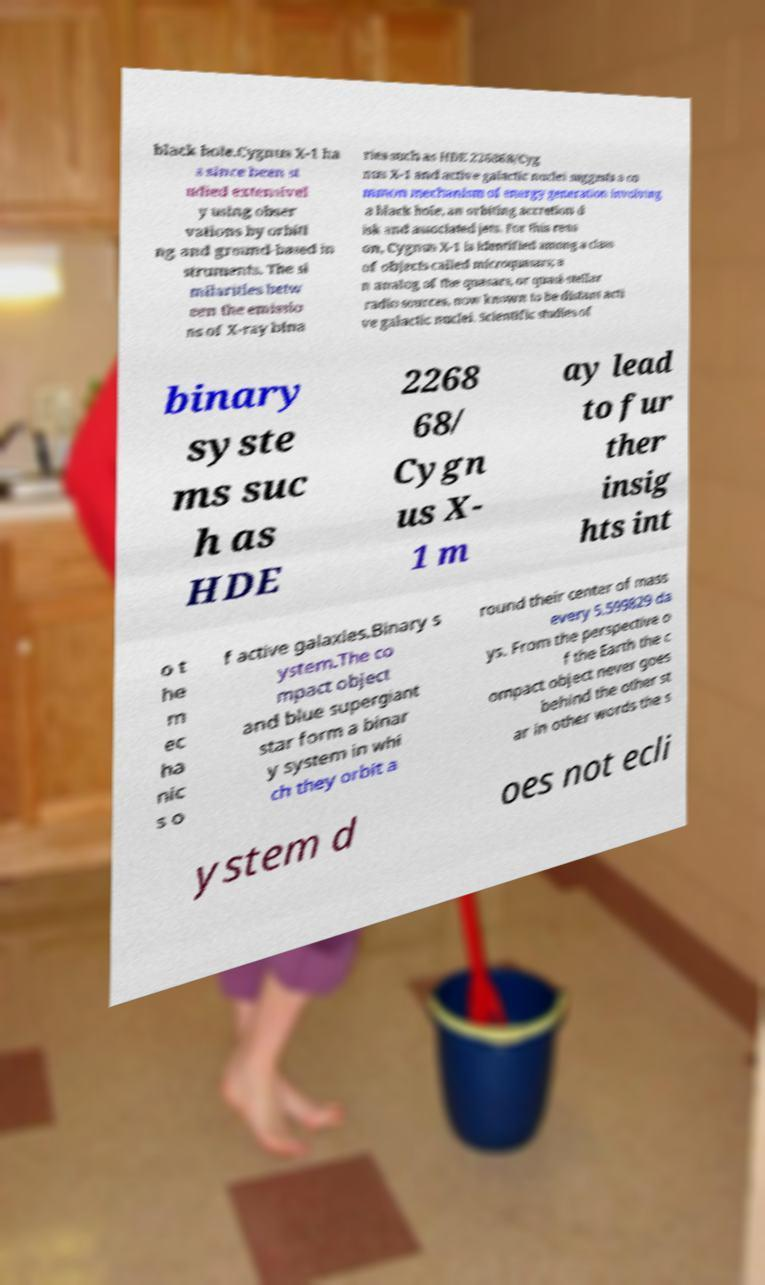Can you accurately transcribe the text from the provided image for me? black hole.Cygnus X-1 ha s since been st udied extensivel y using obser vations by orbiti ng and ground-based in struments. The si milarities betw een the emissio ns of X-ray bina ries such as HDE 226868/Cyg nus X-1 and active galactic nuclei suggests a co mmon mechanism of energy generation involving a black hole, an orbiting accretion d isk and associated jets. For this reas on, Cygnus X-1 is identified among a class of objects called microquasars; a n analog of the quasars, or quasi-stellar radio sources, now known to be distant acti ve galactic nuclei. Scientific studies of binary syste ms suc h as HDE 2268 68/ Cygn us X- 1 m ay lead to fur ther insig hts int o t he m ec ha nic s o f active galaxies.Binary s ystem.The co mpact object and blue supergiant star form a binar y system in whi ch they orbit a round their center of mass every 5.599829 da ys. From the perspective o f the Earth the c ompact object never goes behind the other st ar in other words the s ystem d oes not ecli 